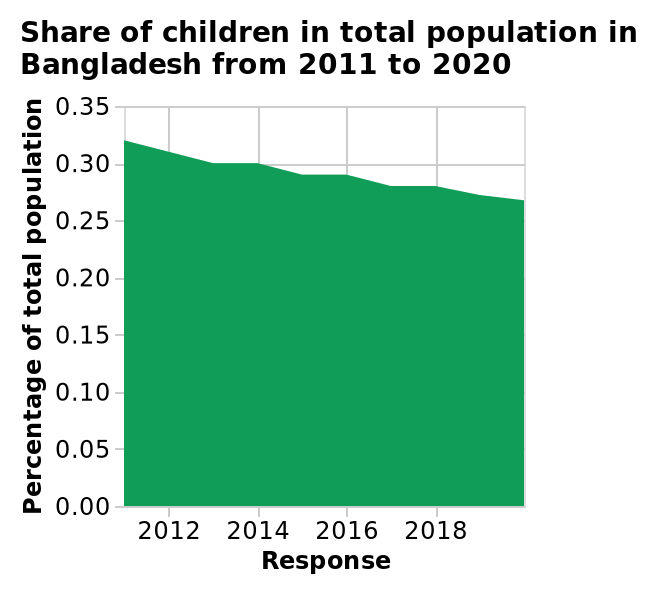<image>
What happened to the share of children from 2012 to 2018?  The share of children decreased between 2012 and 2018. Did the share of children increase between 2012 and 2018? No. The share of children decreased between 2012 and 2018. 